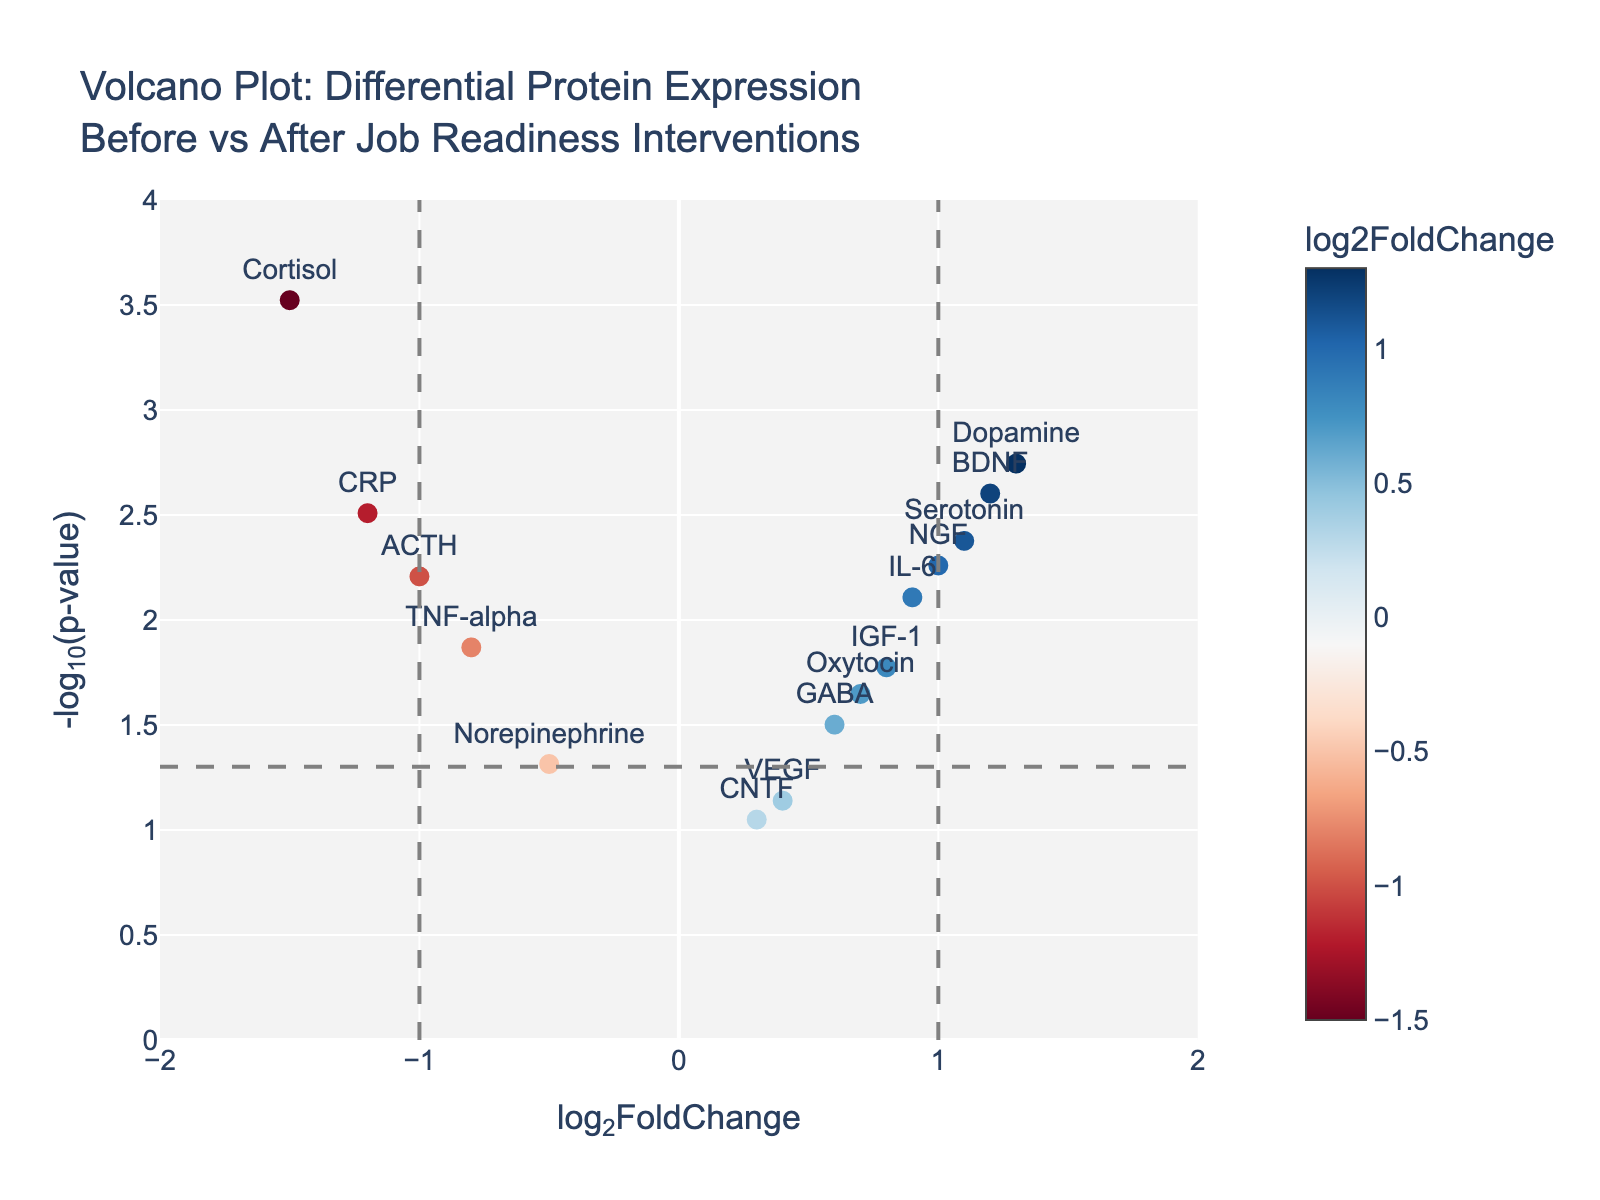What's the title of the figure? The title is usually found at the top of the figure. It sums up the content of the plot.
Answer: Volcano Plot: Differential Protein Expression Before vs After Job Readiness Interventions What's the axis label for the y-axis? The y-axis label is typically located on the vertical axis, providing information about what the axis represents.
Answer: -log10(p-value) How many proteins have a log2FoldChange greater than 1? By counting the data points on the plot with log2FoldChange values greater than 1, you can determine the number. Specifically, observe the proteins on the right side of the vertical line at log2FoldChange = 1.
Answer: 4 Which protein has the highest -log10(p-value)? Identify the data point that is located highest on the y-axis, as that indicates the highest -log10(p-value).
Answer: Cortisol Are there more upregulated proteins (log2FoldChange > 0) or downregulated proteins (log2FoldChange < 0)? Count the number of data points on the right and left sides of the log2FoldChange = 0 line. Compare the two counts.
Answer: More upregulated In which range do most data points fall along the y-axis? Assess the distribution of the data points along the y-axis and identify the range where the density is highest.
Answer: 0.5 to 2.0 Which protein shows the largest downregulation? The largest downregulation corresponds to the most negative log2FoldChange. Look for the data point furthest to the left.
Answer: Cortisol How many proteins have statistically significant changes at p < 0.05? Count the number of data points above the horizontal line at -log10(0.05), as these represent p-values below 0.05.
Answer: 9 What are the coordinates (log2FoldChange and -log10(p-value)) for the protein NGF? Locate the data point labeled NGF on the plot and read its x and y coordinates.
Answer: (1.0, 2.26) Which protein has a log2FoldChange closest to zero but still significant (p < 0.05)? Find the protein closest to the x-axis line at log2FoldChange = 0 and above the significance threshold line.
Answer: GABA 